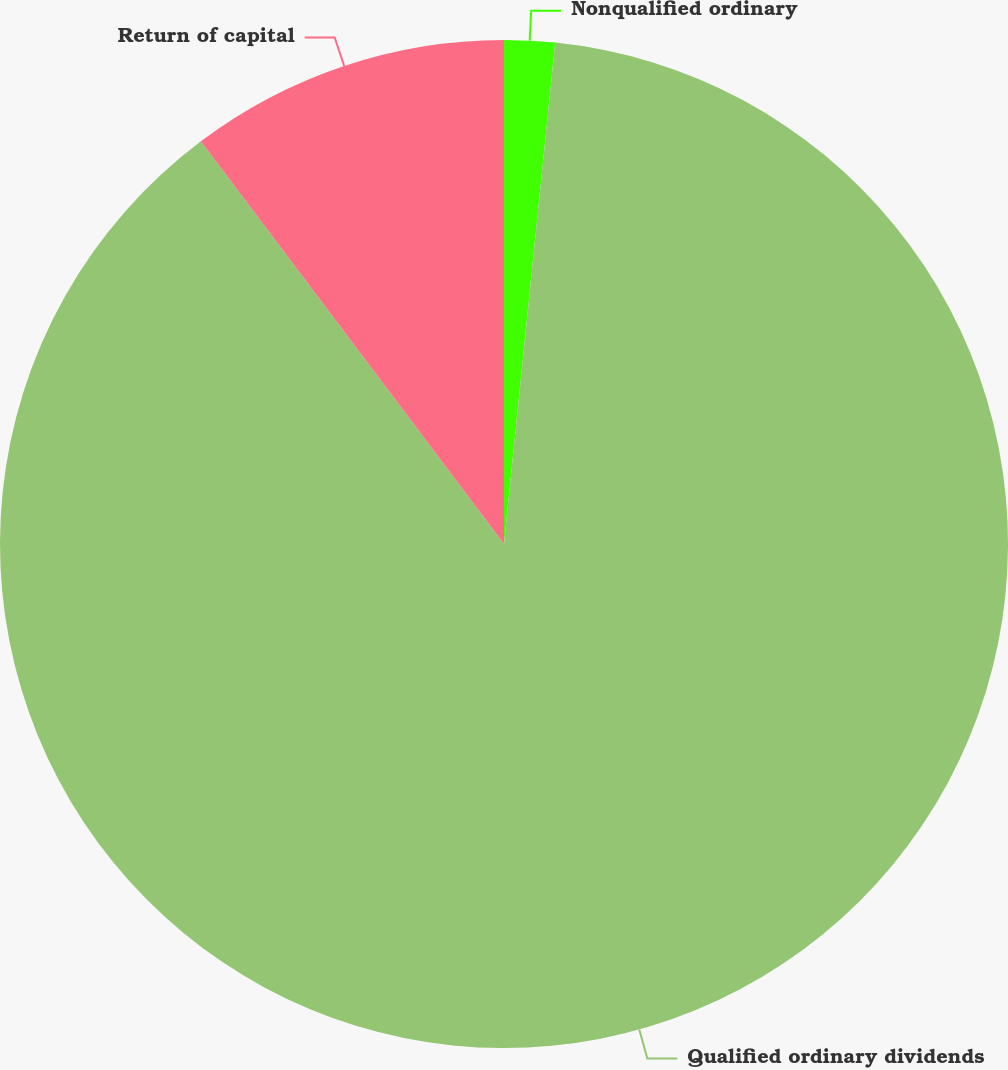Convert chart. <chart><loc_0><loc_0><loc_500><loc_500><pie_chart><fcel>Nonqualified ordinary<fcel>Qualified ordinary dividends<fcel>Return of capital<nl><fcel>1.62%<fcel>88.11%<fcel>10.27%<nl></chart> 